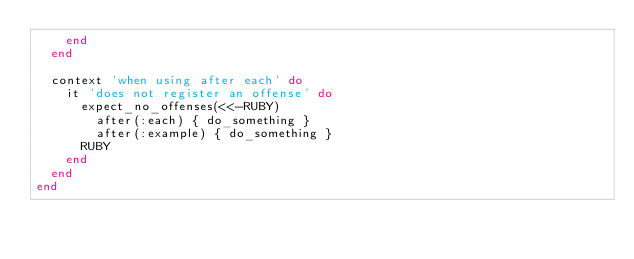Convert code to text. <code><loc_0><loc_0><loc_500><loc_500><_Ruby_>    end
  end

  context 'when using after each' do
    it 'does not register an offense' do
      expect_no_offenses(<<-RUBY)
        after(:each) { do_something }
        after(:example) { do_something }
      RUBY
    end
  end
end
</code> 